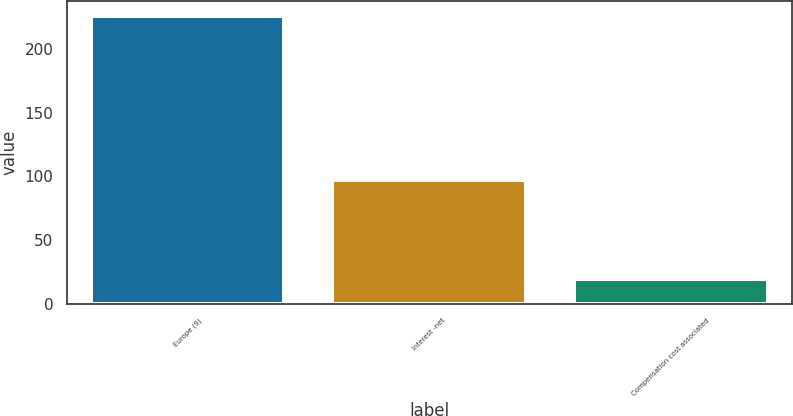<chart> <loc_0><loc_0><loc_500><loc_500><bar_chart><fcel>Europe (9)<fcel>Interest -net<fcel>Compensation cost associated<nl><fcel>226<fcel>97<fcel>20<nl></chart> 